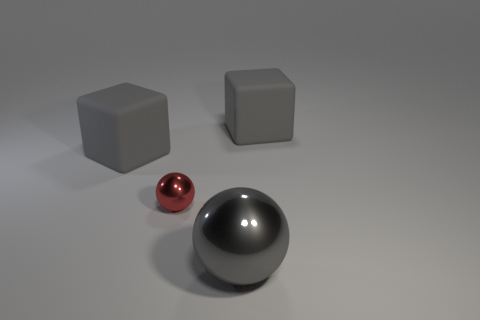Are there any other things that have the same material as the small red ball?
Make the answer very short. Yes. How many objects are either large gray blocks that are on the right side of the tiny red shiny object or big objects?
Offer a terse response. 3. Are there any gray cubes that are in front of the small shiny sphere behind the large gray shiny object that is on the right side of the red metal object?
Your answer should be compact. No. How many metallic balls are there?
Your response must be concise. 2. How many objects are either gray blocks to the left of the gray metallic thing or gray metal objects on the right side of the small metal sphere?
Make the answer very short. 2. There is a gray metallic sphere in front of the red shiny thing; does it have the same size as the tiny red sphere?
Your answer should be compact. No. The other gray metallic thing that is the same shape as the small metallic object is what size?
Make the answer very short. Large. What material is the tiny red thing that is the same shape as the big gray shiny thing?
Your answer should be very brief. Metal. How many other things are the same size as the gray metallic thing?
Ensure brevity in your answer.  2. How many other small objects are the same color as the small metallic object?
Your answer should be very brief. 0. 